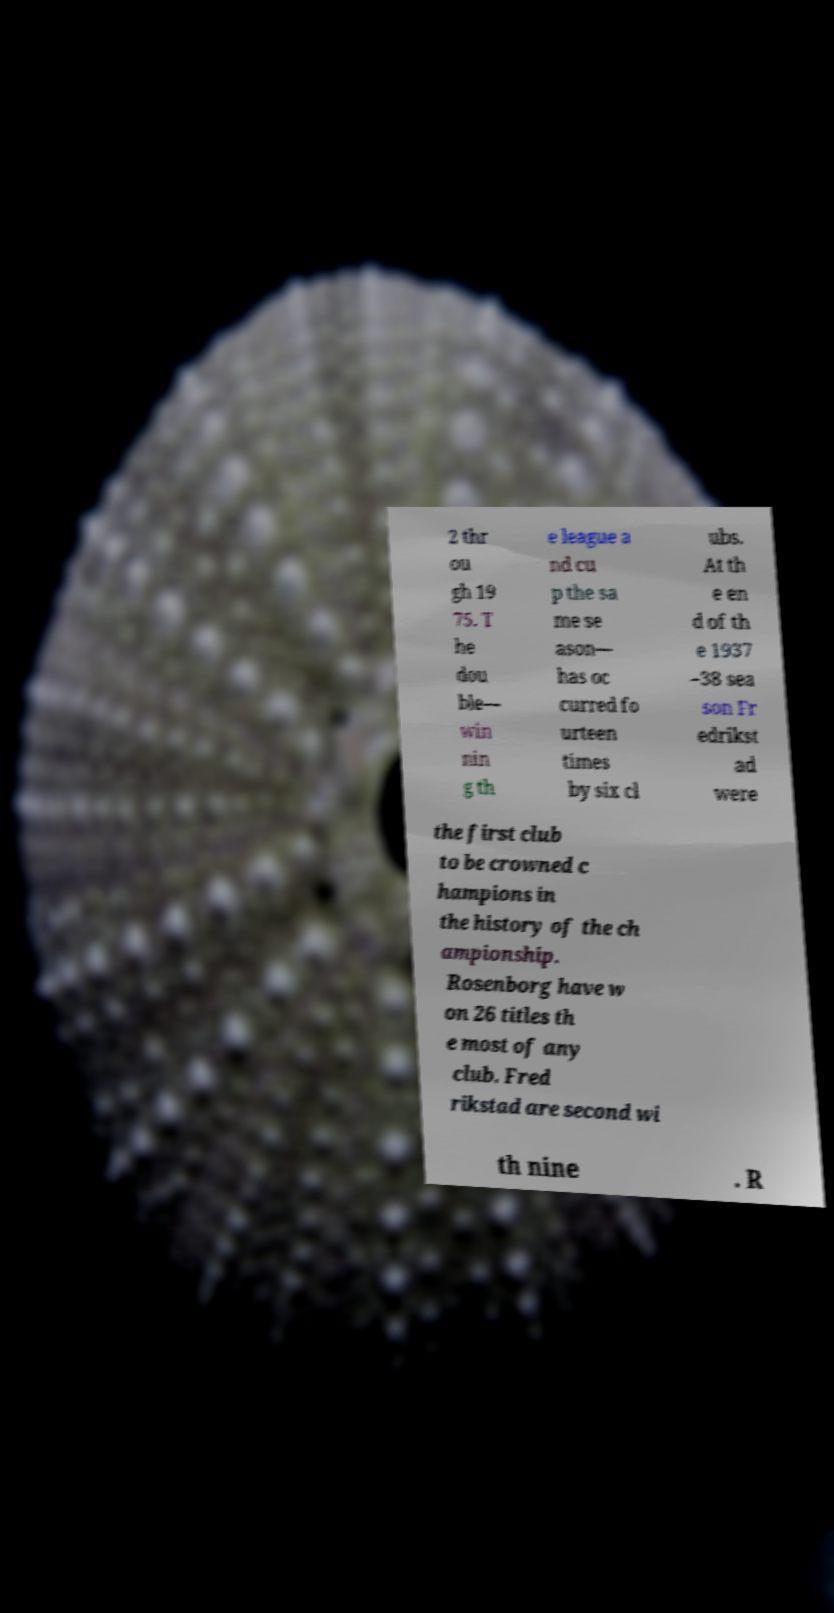Could you extract and type out the text from this image? 2 thr ou gh 19 75. T he dou ble— win nin g th e league a nd cu p the sa me se ason— has oc curred fo urteen times by six cl ubs. At th e en d of th e 1937 –38 sea son Fr edrikst ad were the first club to be crowned c hampions in the history of the ch ampionship. Rosenborg have w on 26 titles th e most of any club. Fred rikstad are second wi th nine . R 